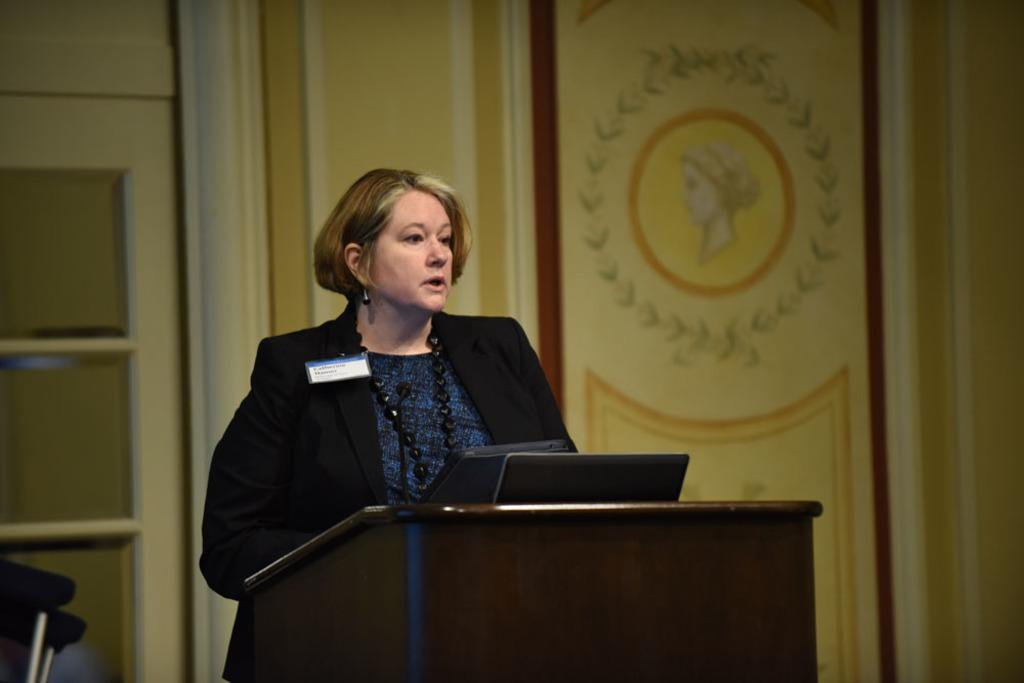What is the woman in the image doing? The woman is standing at a podium in the image. What is on the podium with the woman? There is a microphone and a laptop on the podium. What can be seen in the background of the image? There is a door visible in the image, as well as a picture of a woman on the wall. Can you see the woman's friends playing on the coast in the image? There is no coast or friends visible in the image; it features a woman standing at a podium with a microphone and laptop. 